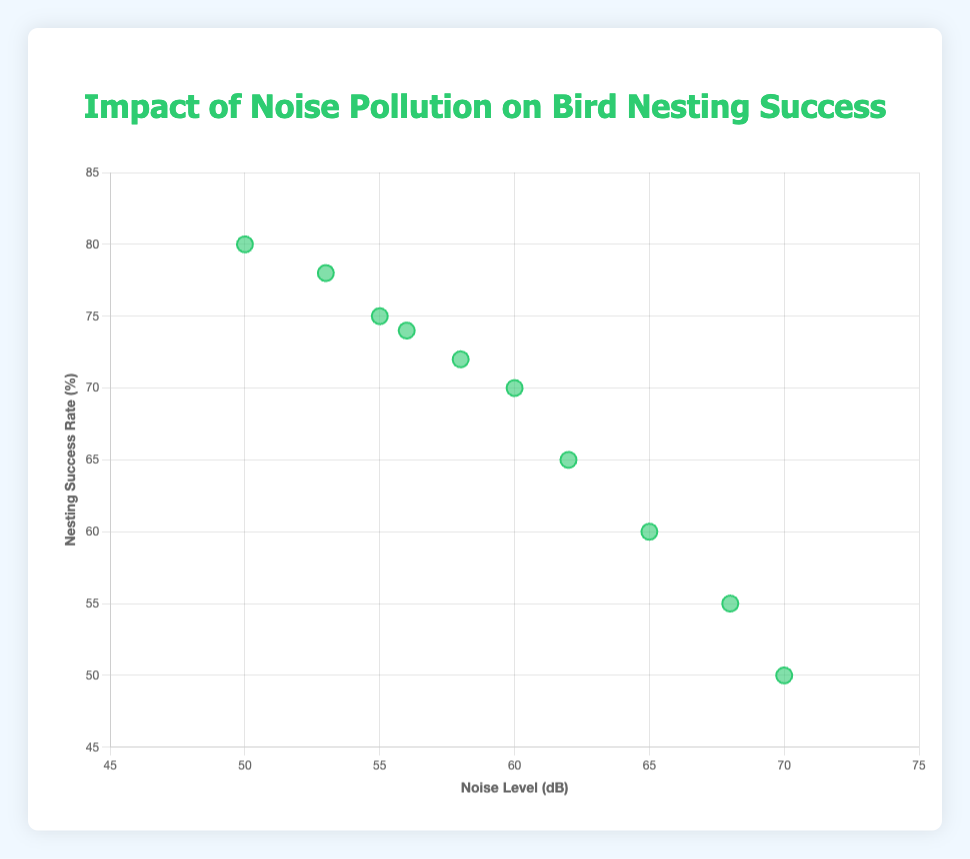How many nesting sites are depicted in the scatter plot? The scatter plot shows 10 individual data points, each representing a different nesting site labeled with its corresponding location.
Answer: 10 What is the noise level at Greenwood Park, and what's its nesting success rate? According to the plot, the data point for Greenwood Park is at (55 dB, 75%), indicating a noise level of 55 dB and a nesting success rate of 75%.
Answer: 55 dB, 75% Which location has the highest nesting success rate, and what is it? The data point for Lakeside Community is at (50 dB, 80%), which is the highest nesting success rate in the plot.
Answer: Lakeside Community, 80% Compare the noise levels between Oakridge and Cedarvale. Which has a higher value? Oakridge has a noise level of 68 dB, while Cedarvale has a noise level of 70 dB. Cedarvale has a higher noise level.
Answer: Cedarvale Is there a general trend between noise level and nesting success rate observed in the scatter plot? Generally, as the noise level increases, the nesting success rate tends to decrease. This can be observed by the downward trend among the points plotted, with higher noise levels associated with lower nesting success rates.
Answer: Negative trend What are the coordinates for the data point that represents Willowbrook? The data point representing Willowbrook is at (53 dB, 78%), as shown on the scatter plot.
Answer: 53 dB, 78% Which location has almost the same noise level as Riverside but a higher nesting success rate? Brighton Gardens has a noise level of 56 dB and a nesting success rate of 74%, which is very close to Riverside's noise level of 58 dB but with a higher nesting success rate.
Answer: Brighton Gardens If you were to find the average noise level for all the locations, what would it be? Summing up the noise levels: 55 + 60 + 65 + 50 + 68 + 58 + 62 + 53 + 70 + 56 = 597 dB. There are 10 locations, so the average noise level is 597 / 10 = 59.7 dB.
Answer: 59.7 dB Which location has the lowest nesting success rate, and what noise level is it associated with? The data point for Cedarvale is at (70 dB, 50%), which is the lowest nesting success rate in the plot, and it's associated with a noise level of 70 dB.
Answer: Cedarvale, 50% 